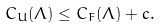Convert formula to latex. <formula><loc_0><loc_0><loc_500><loc_500>C _ { U } ( \Lambda ) \leq C _ { F } ( \Lambda ) + c .</formula> 